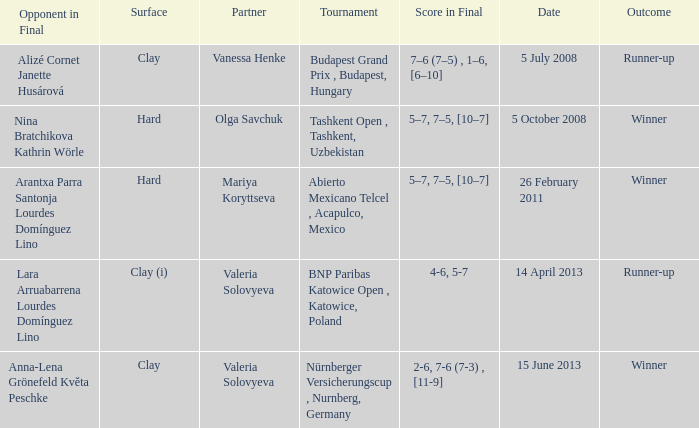Name the outcome for alizé cornet janette husárová being opponent in final Runner-up. 